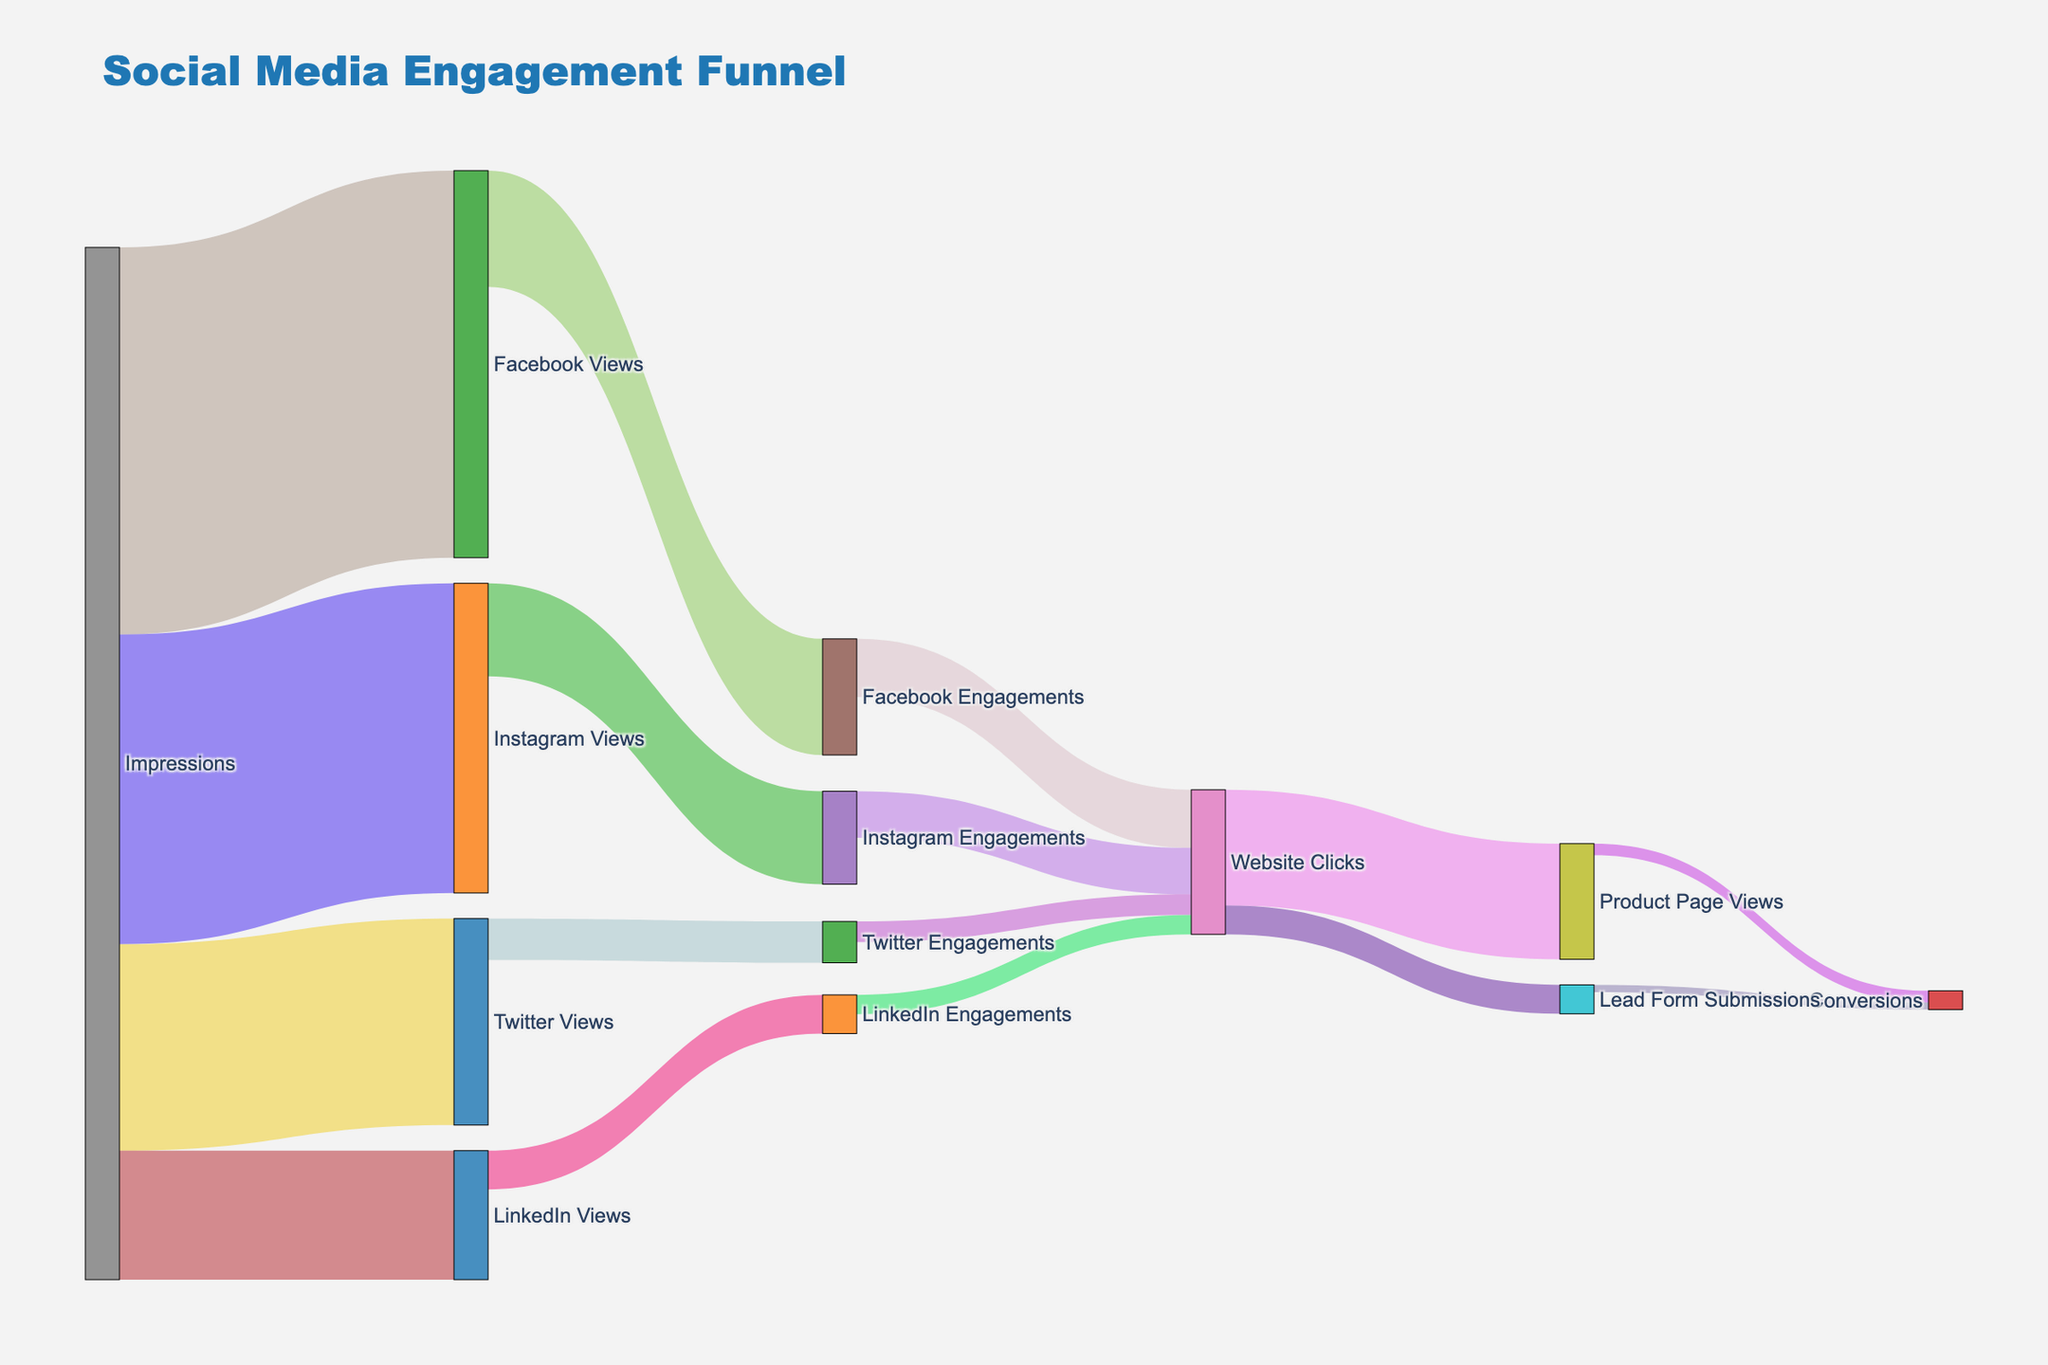what is the total number of impressions across all social media platforms? To find the total number of impressions, sum the values of all impressions: 150000 (Facebook) + 120000 (Instagram) + 80000 (Twitter) + 50000 (LinkedIn). The total is 150000 + 120000 + 80000 + 50000 = 400000.
Answer: 400000 Which social media platform has the highest number of engagements? The highest number of engagements is the value leading to the various engagements nodes: 45000 (Facebook), 36000 (Instagram), 16000 (Twitter), 15000 (LinkedIn). Facebook has the highest number of engagements at 45000.
Answer: Facebook How many lead form submissions came from the website clicks? Website Clicks lead to 11200 Lead Form Submissions. This value is marked clearly in the plot.
Answer: 11200 Which type of conversion has a higher value: from lead form submissions or from product page views? Identify conversions from Lead Form Submissions (2800) and from Product Page Views (4480). Product Page Views have higher conversions.
Answer: Product Page Views What's the total number of conversions from the two types of website clicks? Add the conversions from Lead Form Submissions (2800) and Product Page Views (4480). 2800 + 4480 = 7280.
Answer: 7280 Which has more Website Clicks: engagements on Facebook or Instagram? From the plot, Facebook Engagements (22500) compared to Instagram Engagements (18000), Facebook has more Website Clicks.
Answer: Facebook How many impressions did not result in any views across all platforms? Total Impressions = 400000. Sum of all Views are: 150000 (Facebook) + 120000 (Instagram) + 80000 (Twitter) + 50000 (LinkedIn) = 400000. Since all impressions convert to some views, none are unconverted.
Answer: 0 How does the number of Product Page Views compare to the number of Website Clicks? Product Page Views (44800) and Website Clicks (Overall): 22500 (Facebook) + 18000 (Instagram) + 8000 (Twitter) + 7500 (LinkedIn) = 56000. Product Page Views are fewer than Website Clicks.
Answer: Fewer What fraction of Instagram Views resulted in Instagram Engagements? Instagram Views: 120000, Instagram Engagements: 36000. Fraction = 36000 / 120000 = 0.3.
Answer: 0.3 Which social media platform has the least effective conversions from impressions? Compare Impressions to Conversions across platforms. Calculating:
Facebook: 150000 (impressions) → 4480 + 2800 (conversions via interactions) ≈ 7280 total,
Instagram: 120000 → same 7280 total from same values,
Twitter: 2800+ and LinkedIn ≈ 2000 
Comparison shows Twitter gives lowest.
Answer: Twitter 